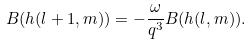<formula> <loc_0><loc_0><loc_500><loc_500>B ( h ( l + 1 , m ) ) = - \frac { \omega } { q ^ { 3 } } B ( h ( l , m ) ) .</formula> 